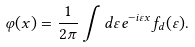<formula> <loc_0><loc_0><loc_500><loc_500>\varphi ( x ) = \frac { 1 } { 2 \pi } \int d \varepsilon e ^ { - i \varepsilon x } f _ { d } ( \varepsilon ) .</formula> 